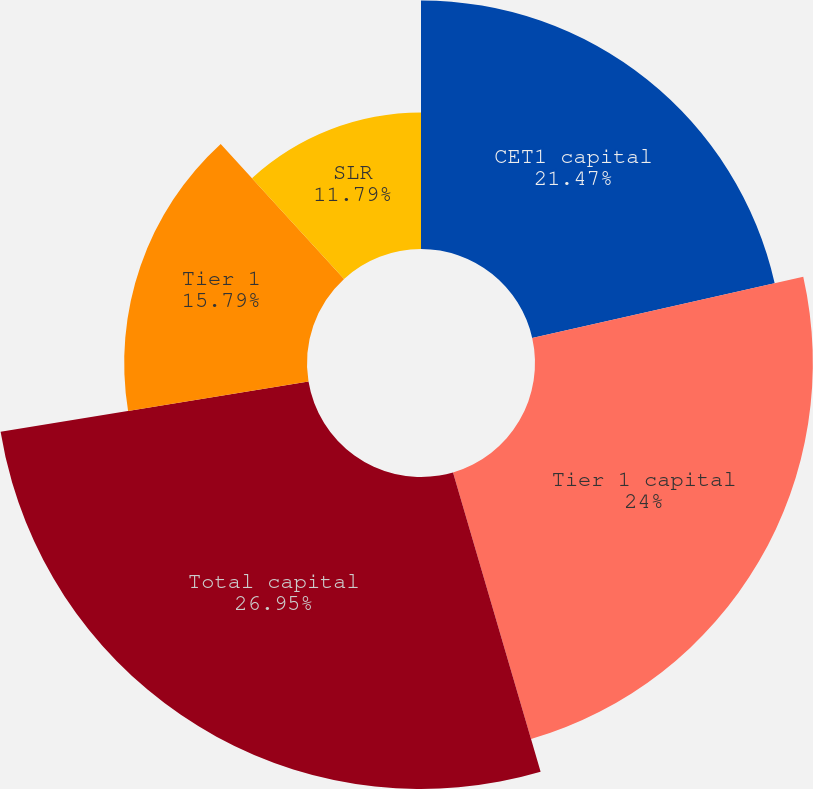Convert chart. <chart><loc_0><loc_0><loc_500><loc_500><pie_chart><fcel>CET1 capital<fcel>Tier 1 capital<fcel>Total capital<fcel>Tier 1<fcel>SLR<nl><fcel>21.47%<fcel>24.0%<fcel>26.95%<fcel>15.79%<fcel>11.79%<nl></chart> 